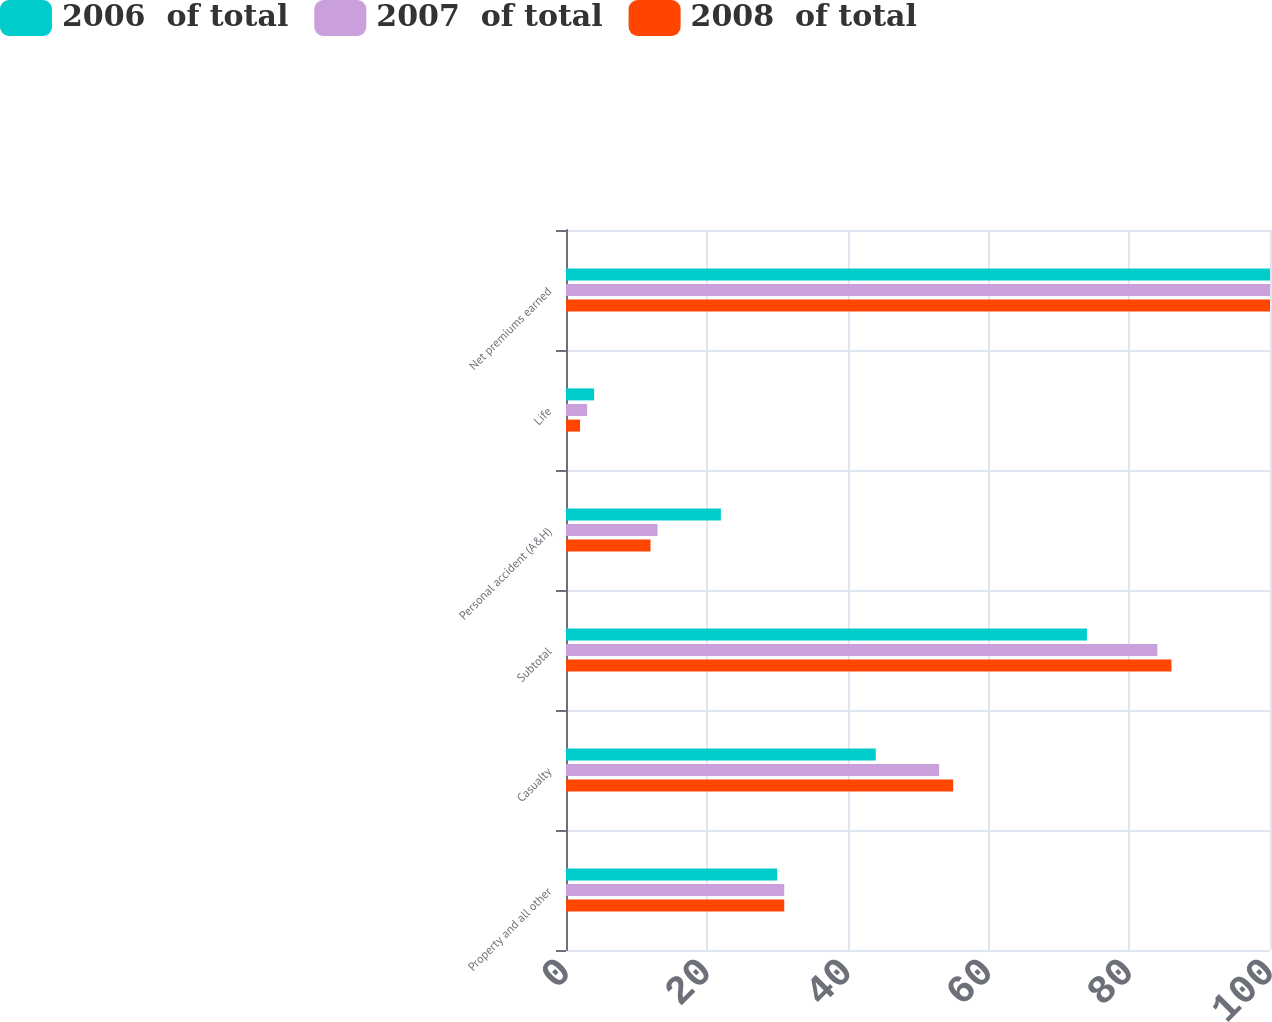Convert chart. <chart><loc_0><loc_0><loc_500><loc_500><stacked_bar_chart><ecel><fcel>Property and all other<fcel>Casualty<fcel>Subtotal<fcel>Personal accident (A&H)<fcel>Life<fcel>Net premiums earned<nl><fcel>2006  of total<fcel>30<fcel>44<fcel>74<fcel>22<fcel>4<fcel>100<nl><fcel>2007  of total<fcel>31<fcel>53<fcel>84<fcel>13<fcel>3<fcel>100<nl><fcel>2008  of total<fcel>31<fcel>55<fcel>86<fcel>12<fcel>2<fcel>100<nl></chart> 